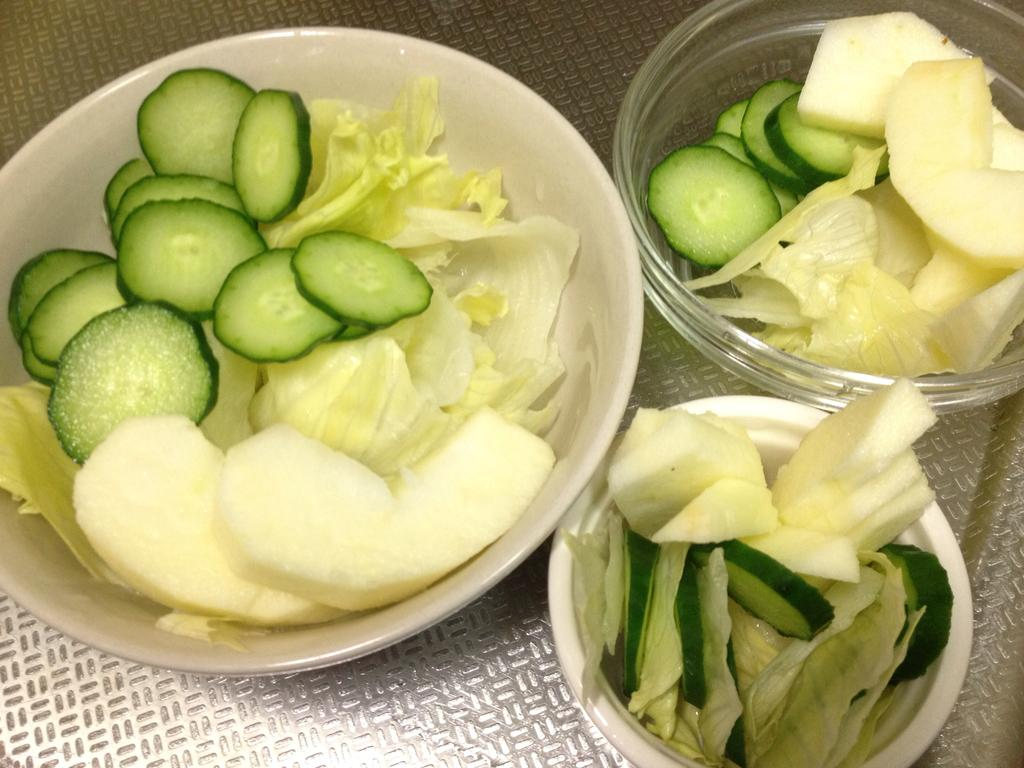What type of objects can be seen in the image? There are food items in the image. How are the food items arranged or presented? The food items are in bowls. What type of grape is used to measure the distance between the bowls in the image? There are no grapes or measuring devices present in the image, and the distance between the bowls is not mentioned. 